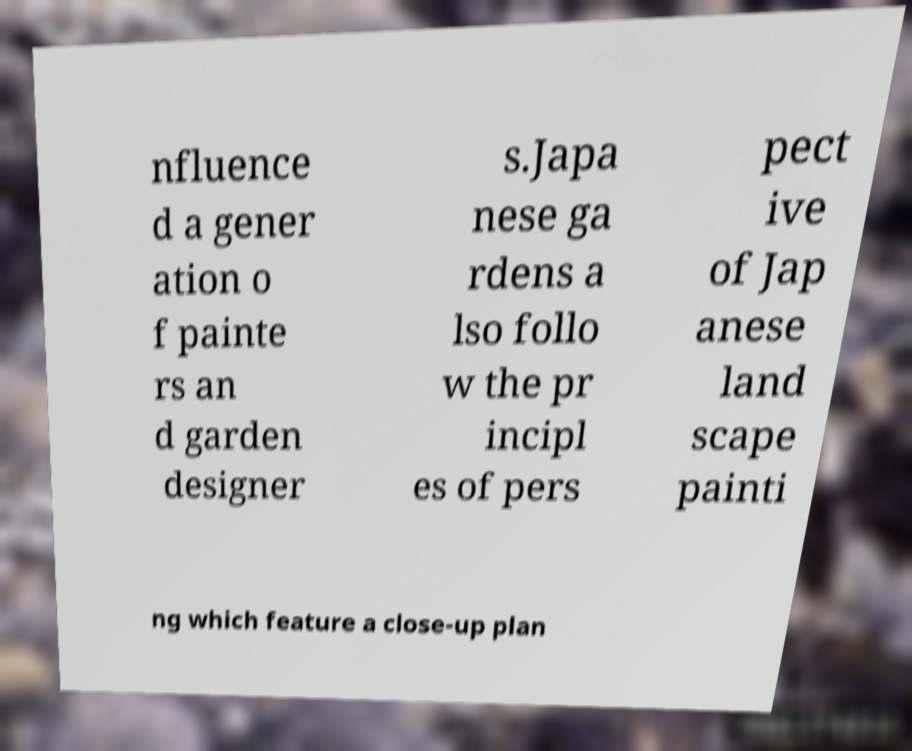I need the written content from this picture converted into text. Can you do that? nfluence d a gener ation o f painte rs an d garden designer s.Japa nese ga rdens a lso follo w the pr incipl es of pers pect ive of Jap anese land scape painti ng which feature a close-up plan 